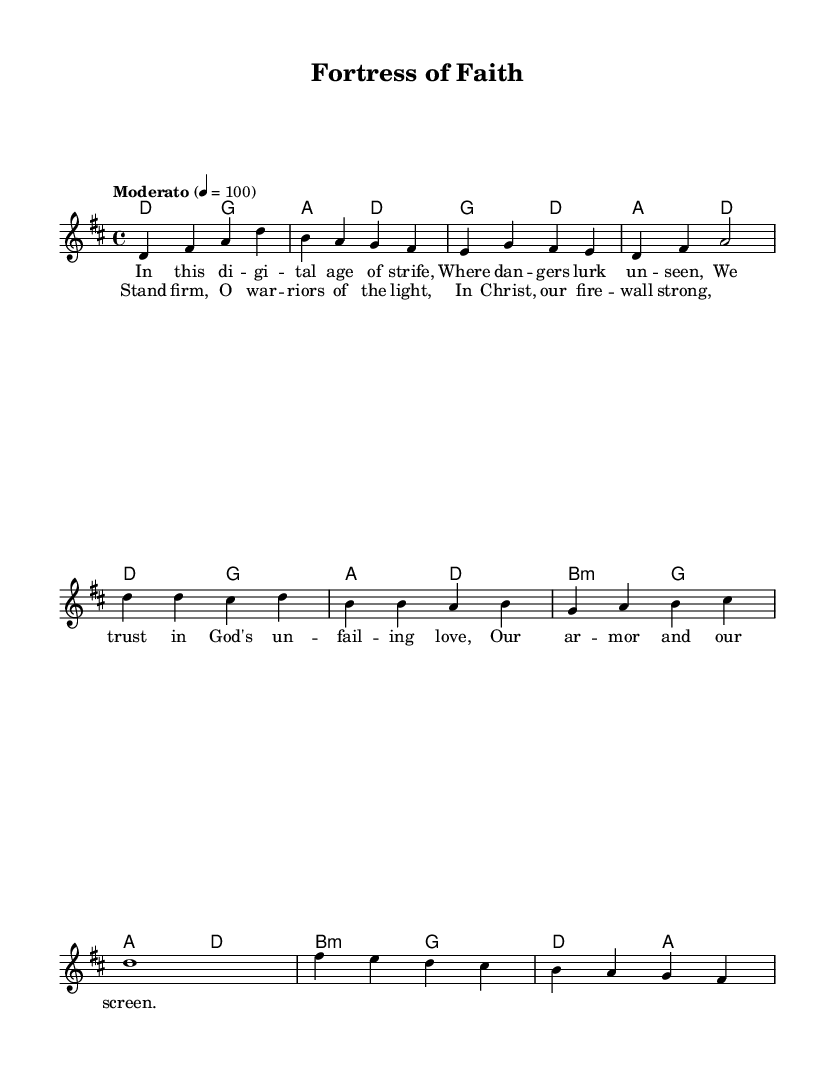What is the key signature of this music? The key signature is D major, which has two sharps (F# and C#).
Answer: D major What is the time signature of this music? The time signature is 4/4, which indicates four beats in a measure and a quarter note receives one beat.
Answer: 4/4 What is the tempo marking of the piece? The tempo marking is "Moderato," indicating a moderate pace, typically around 100 beats per minute.
Answer: Moderato How many verses are in the hymn? There is one verse provided in the sheet music. This is determined by examining the song structure, where the lyrics for the verse are written out without repetition.
Answer: One What is the primary theme of the lyrics? The primary theme is trust in God's protection and strength during struggles, reflecting a spiritual warfare perspective. This can be interpreted from phrases in the lyrics indicating reliance on divine love and armor.
Answer: Trust What is the first line of the chorus? The first line of the chorus is "Stand firm, O warriors of the light," which establishes a direct call to action for spiritual vigilance.
Answer: Stand firm, O warriors of the light What type of musical form does the hymn follow? The hymn follows a verse-chorus structure, common in religious music, where a verse presents the message followed by a repetitive chorus reinforcing that message.
Answer: Verse-chorus 